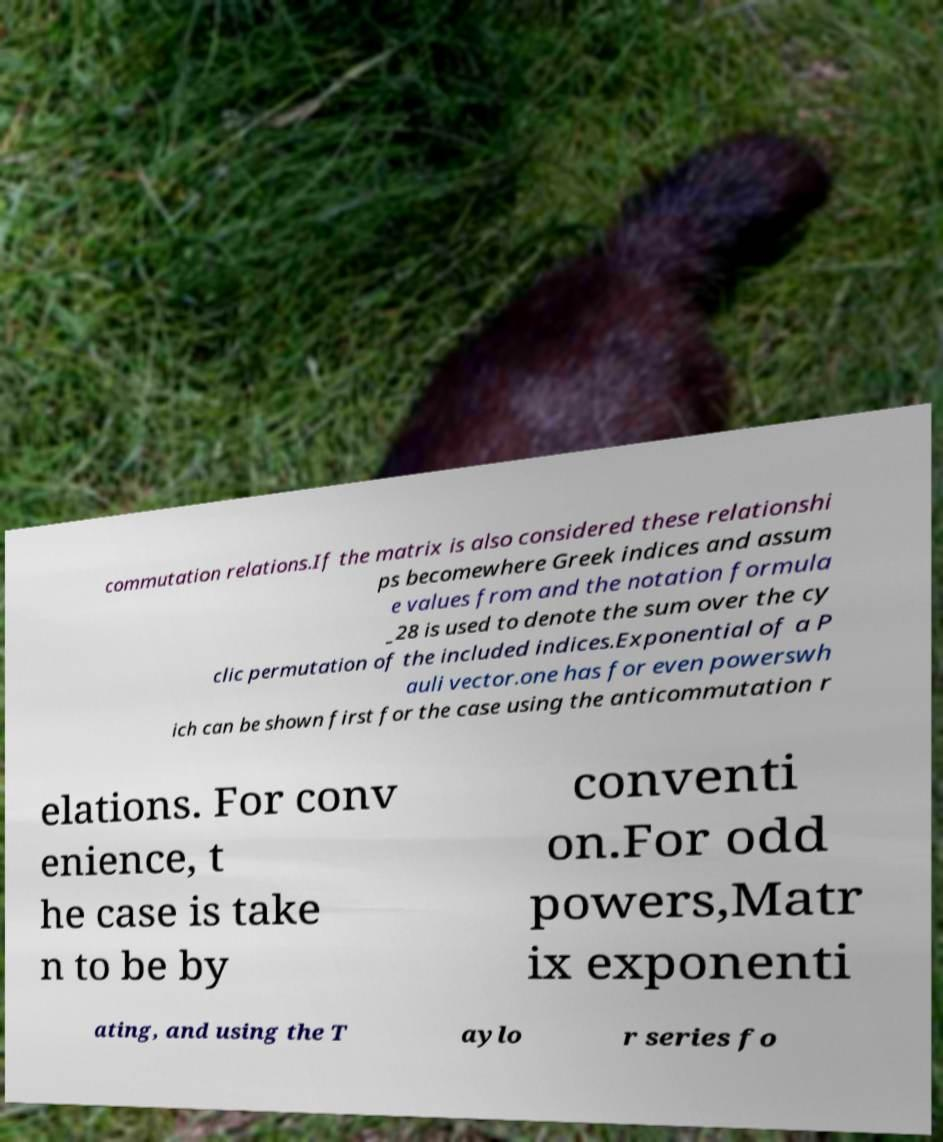Can you accurately transcribe the text from the provided image for me? commutation relations.If the matrix is also considered these relationshi ps becomewhere Greek indices and assum e values from and the notation formula _28 is used to denote the sum over the cy clic permutation of the included indices.Exponential of a P auli vector.one has for even powerswh ich can be shown first for the case using the anticommutation r elations. For conv enience, t he case is take n to be by conventi on.For odd powers,Matr ix exponenti ating, and using the T aylo r series fo 